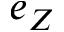Convert formula to latex. <formula><loc_0><loc_0><loc_500><loc_500>e _ { Z }</formula> 